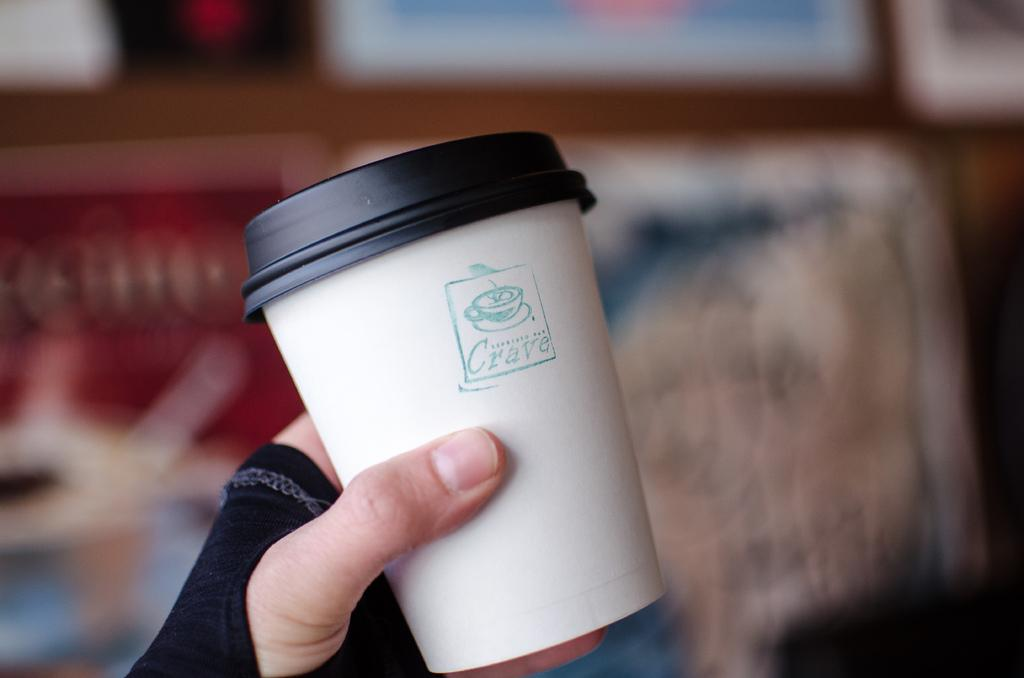What is the main subject of the image? The main subject of the image is a guy. What is the guy holding in the image? The guy is holding a cup. What is the name of the cup? The cup is named Crave. Can you describe the background of the image? The background of the image is blurred. What type of record can be seen spinning on the table in the image? There is no record present in the image. How does the guy twist the coal in the image? There is no coal present in the image, and the guy is not shown twisting anything. 